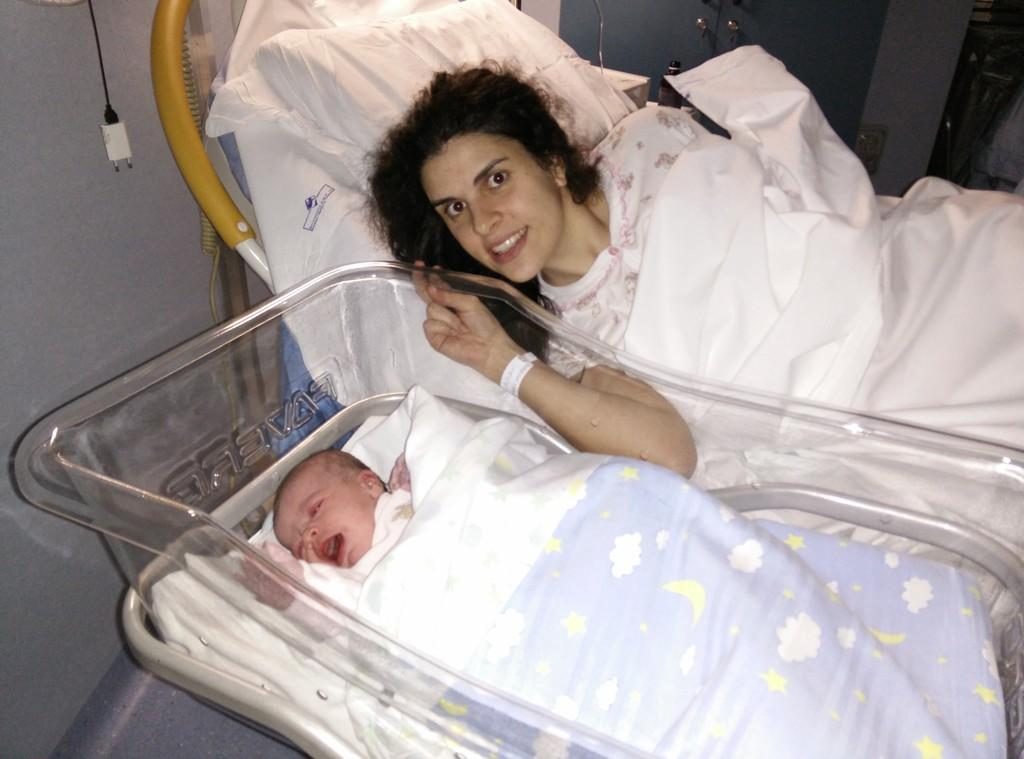Who is the main subject in the image? There is a woman in the image. What is the woman doing in the image? The woman is sitting on a bed and posing for a picture. Is there anyone else in the image besides the woman? Yes, there is a newborn baby in the image. What is the baby doing in the image? The baby is sleeping in a cradle. What type of fairies can be seen flying around the baby in the image? There are no fairies present in the image. What organization is responsible for the baby's cradle in the image? There is no information about an organization responsible for the baby's cradle in the image. 